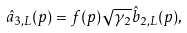Convert formula to latex. <formula><loc_0><loc_0><loc_500><loc_500>\hat { a } _ { 3 , L } ( p ) = f ( p ) \sqrt { \gamma _ { 2 } } \hat { b } _ { 2 , L } ( p ) ,</formula> 